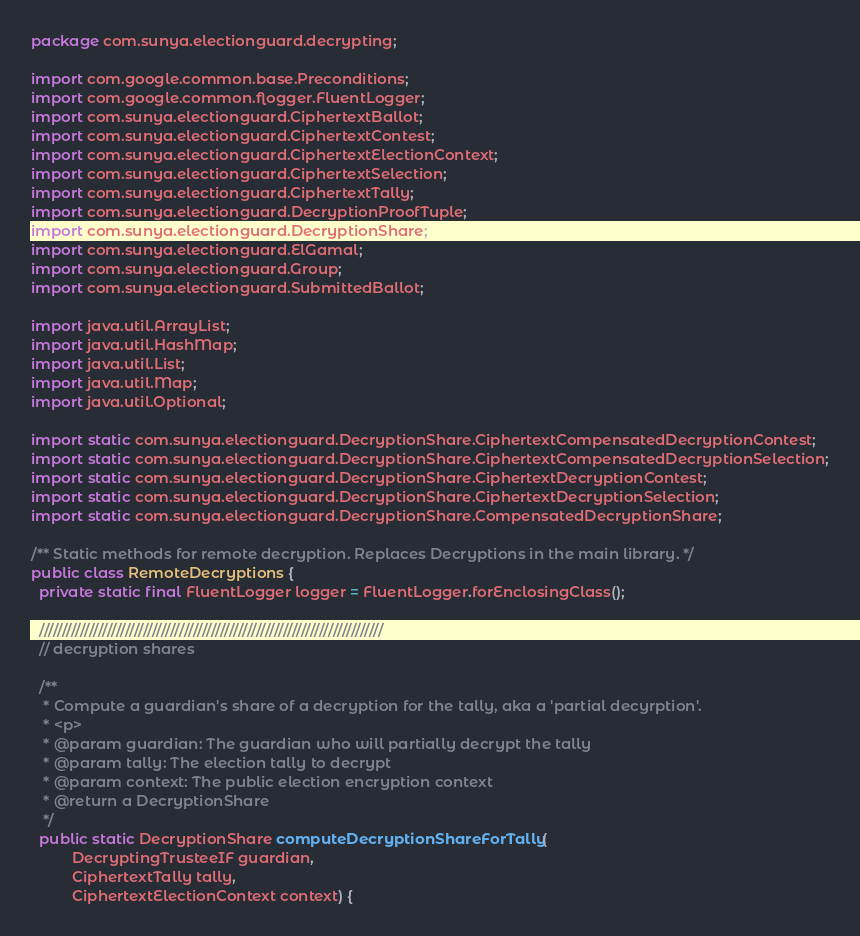<code> <loc_0><loc_0><loc_500><loc_500><_Java_>package com.sunya.electionguard.decrypting;

import com.google.common.base.Preconditions;
import com.google.common.flogger.FluentLogger;
import com.sunya.electionguard.CiphertextBallot;
import com.sunya.electionguard.CiphertextContest;
import com.sunya.electionguard.CiphertextElectionContext;
import com.sunya.electionguard.CiphertextSelection;
import com.sunya.electionguard.CiphertextTally;
import com.sunya.electionguard.DecryptionProofTuple;
import com.sunya.electionguard.DecryptionShare;
import com.sunya.electionguard.ElGamal;
import com.sunya.electionguard.Group;
import com.sunya.electionguard.SubmittedBallot;

import java.util.ArrayList;
import java.util.HashMap;
import java.util.List;
import java.util.Map;
import java.util.Optional;

import static com.sunya.electionguard.DecryptionShare.CiphertextCompensatedDecryptionContest;
import static com.sunya.electionguard.DecryptionShare.CiphertextCompensatedDecryptionSelection;
import static com.sunya.electionguard.DecryptionShare.CiphertextDecryptionContest;
import static com.sunya.electionguard.DecryptionShare.CiphertextDecryptionSelection;
import static com.sunya.electionguard.DecryptionShare.CompensatedDecryptionShare;

/** Static methods for remote decryption. Replaces Decryptions in the main library. */
public class RemoteDecryptions {
  private static final FluentLogger logger = FluentLogger.forEnclosingClass();

  ////////////////////////////////////////////////////////////////////////////
  // decryption shares

  /**
   * Compute a guardian's share of a decryption for the tally, aka a 'partial decyrption'.
   * <p>
   * @param guardian: The guardian who will partially decrypt the tally
   * @param tally: The election tally to decrypt
   * @param context: The public election encryption context
   * @return a DecryptionShare
   */
  public static DecryptionShare computeDecryptionShareForTally(
          DecryptingTrusteeIF guardian,
          CiphertextTally tally,
          CiphertextElectionContext context) {
</code> 